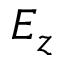Convert formula to latex. <formula><loc_0><loc_0><loc_500><loc_500>E _ { z }</formula> 